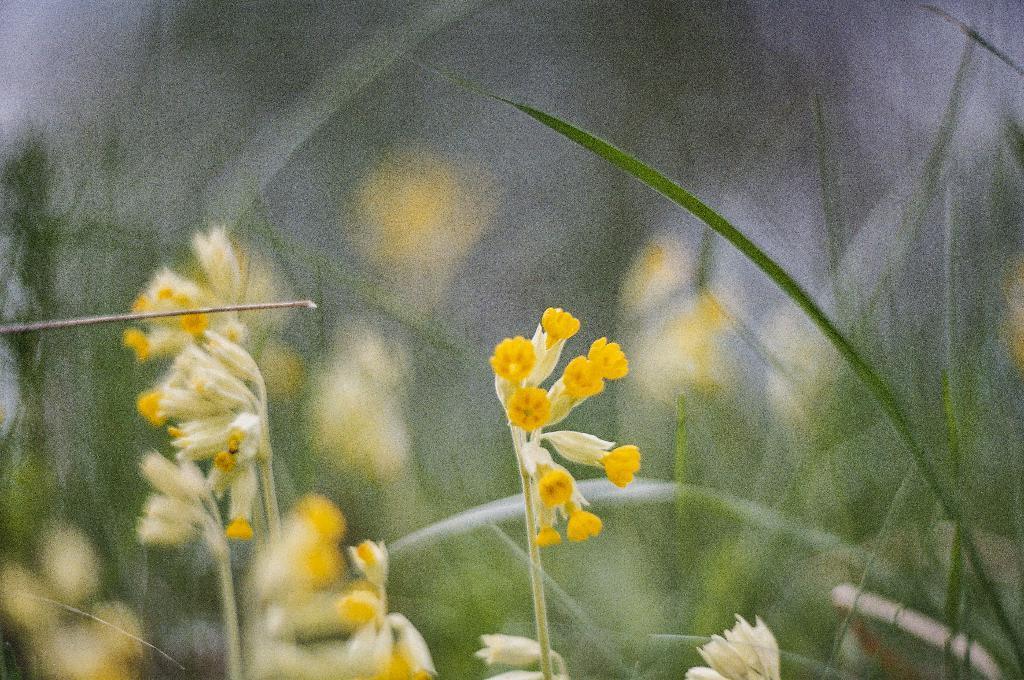Describe this image in one or two sentences. In this image we can see some flowers which are in yellow color and in the background of the image there are some leaves. 